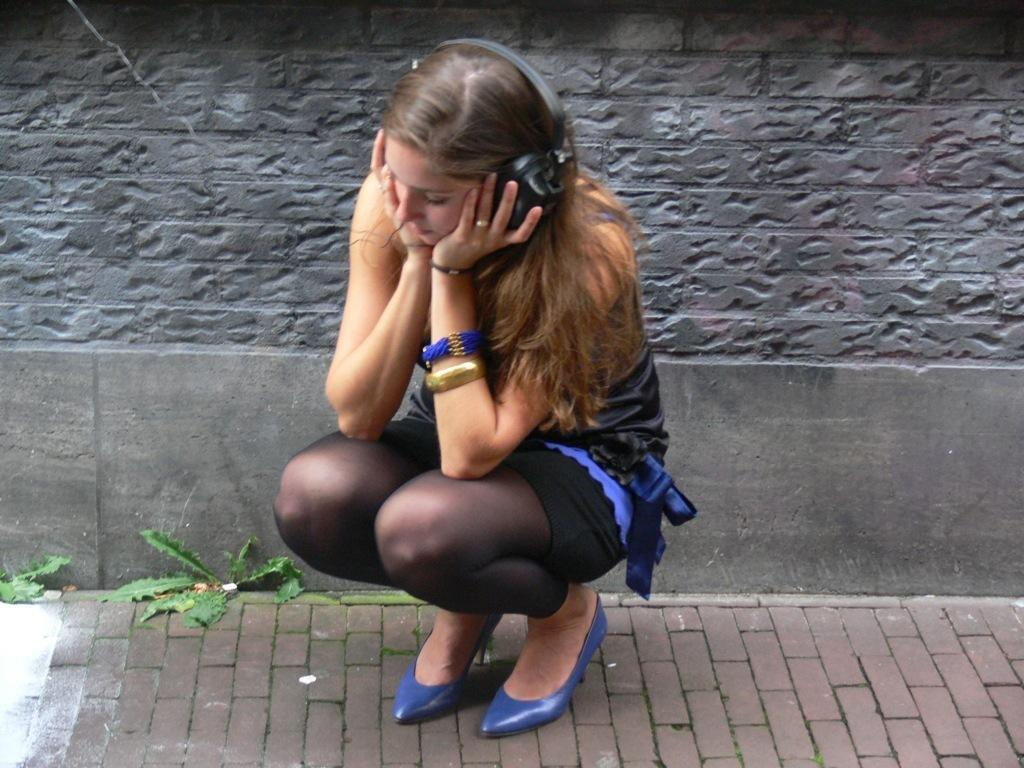Who is present in the image? There is a woman in the image. What type of footwear is the woman wearing? The woman is wearing sandals. What accessories is the woman wearing? The woman is wearing a bracelet and a finger ring. What is the woman using to listen to something in the image? The woman is wearing headsets. How is the woman positioned in the image? The woman is sitting in a squat position. What type of surface can be seen in the image? There is a footpath in the image. What type of vegetation is visible in the image? There are leaves visible in the image. What type of structure is present in the image? There is a wall in the image. What type of furniture is visible in the image? There is no furniture present in the image. What type of sponge is the woman using to clean the wall in the image? There is no sponge or cleaning activity depicted in the image. 